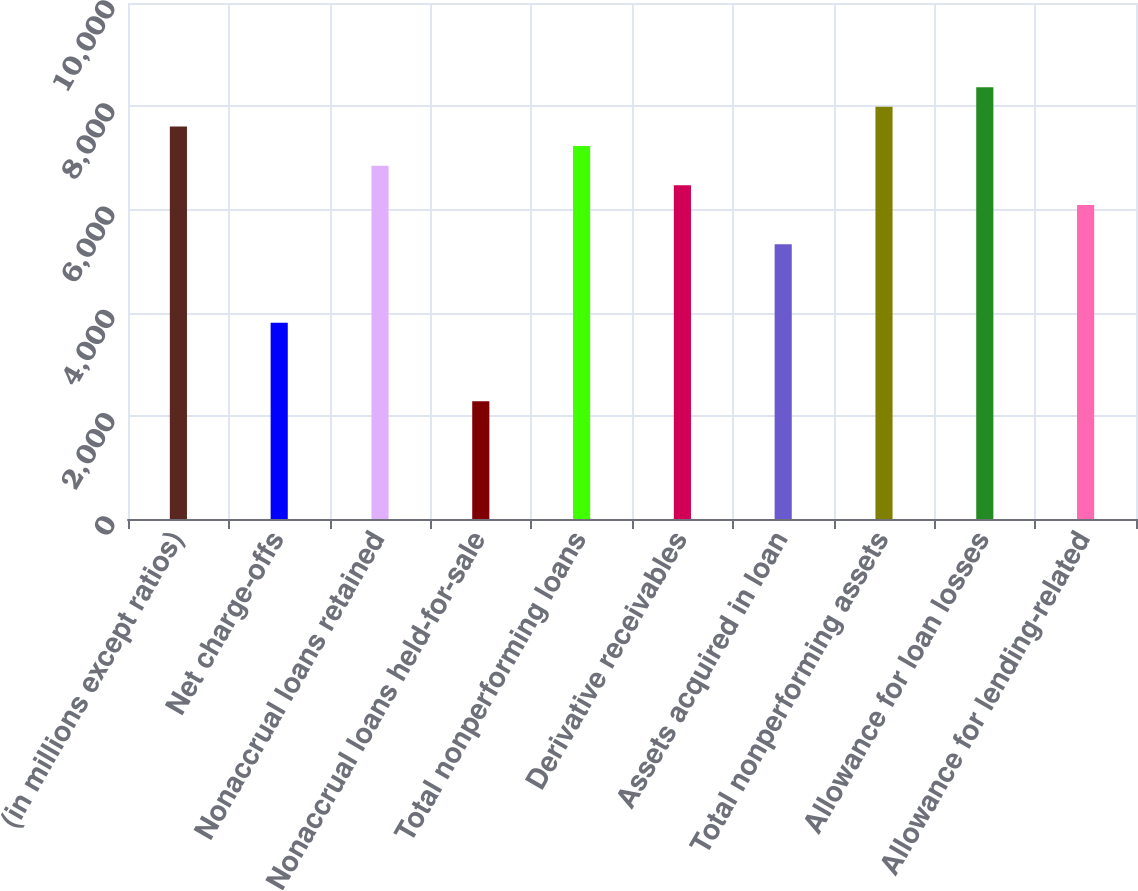<chart> <loc_0><loc_0><loc_500><loc_500><bar_chart><fcel>(in millions except ratios)<fcel>Net charge-offs<fcel>Nonaccrual loans retained<fcel>Nonaccrual loans held-for-sale<fcel>Total nonperforming loans<fcel>Derivative receivables<fcel>Assets acquired in loan<fcel>Total nonperforming assets<fcel>Allowance for loan losses<fcel>Allowance for lending-related<nl><fcel>7607.94<fcel>3804.04<fcel>6847.16<fcel>2282.48<fcel>7227.55<fcel>6466.77<fcel>5325.6<fcel>7988.33<fcel>8368.72<fcel>6086.38<nl></chart> 